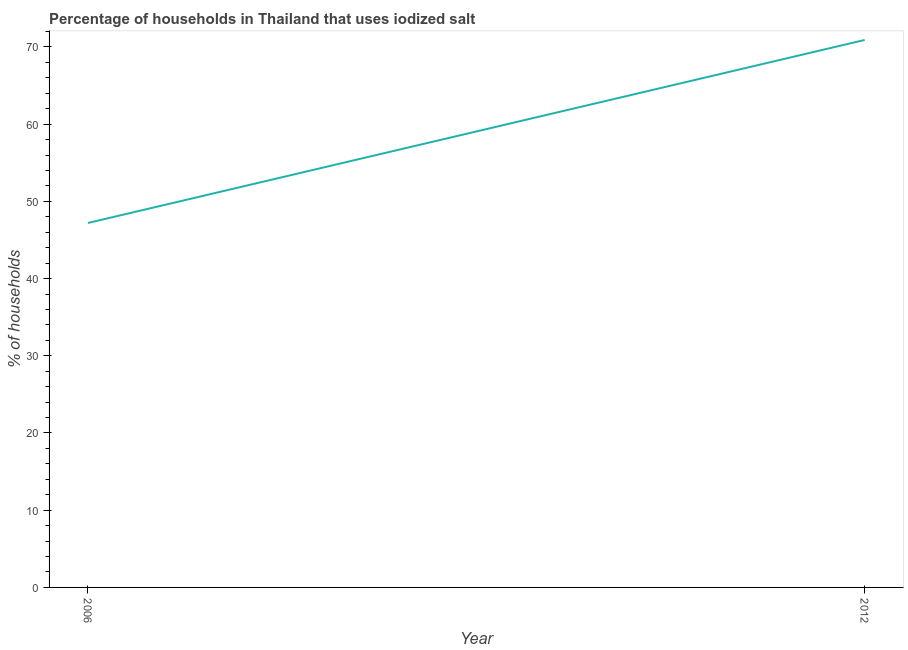What is the percentage of households where iodized salt is consumed in 2012?
Your answer should be very brief. 70.9. Across all years, what is the maximum percentage of households where iodized salt is consumed?
Make the answer very short. 70.9. Across all years, what is the minimum percentage of households where iodized salt is consumed?
Your answer should be compact. 47.2. In which year was the percentage of households where iodized salt is consumed minimum?
Ensure brevity in your answer.  2006. What is the sum of the percentage of households where iodized salt is consumed?
Your answer should be very brief. 118.1. What is the difference between the percentage of households where iodized salt is consumed in 2006 and 2012?
Provide a succinct answer. -23.7. What is the average percentage of households where iodized salt is consumed per year?
Your answer should be very brief. 59.05. What is the median percentage of households where iodized salt is consumed?
Give a very brief answer. 59.05. Do a majority of the years between 2006 and 2012 (inclusive) have percentage of households where iodized salt is consumed greater than 10 %?
Ensure brevity in your answer.  Yes. What is the ratio of the percentage of households where iodized salt is consumed in 2006 to that in 2012?
Give a very brief answer. 0.67. Is the percentage of households where iodized salt is consumed in 2006 less than that in 2012?
Make the answer very short. Yes. In how many years, is the percentage of households where iodized salt is consumed greater than the average percentage of households where iodized salt is consumed taken over all years?
Make the answer very short. 1. Does the percentage of households where iodized salt is consumed monotonically increase over the years?
Offer a terse response. Yes. How many lines are there?
Offer a very short reply. 1. How many years are there in the graph?
Ensure brevity in your answer.  2. Are the values on the major ticks of Y-axis written in scientific E-notation?
Offer a terse response. No. Does the graph contain grids?
Ensure brevity in your answer.  No. What is the title of the graph?
Provide a short and direct response. Percentage of households in Thailand that uses iodized salt. What is the label or title of the Y-axis?
Provide a succinct answer. % of households. What is the % of households in 2006?
Provide a short and direct response. 47.2. What is the % of households of 2012?
Provide a short and direct response. 70.9. What is the difference between the % of households in 2006 and 2012?
Provide a succinct answer. -23.7. What is the ratio of the % of households in 2006 to that in 2012?
Make the answer very short. 0.67. 